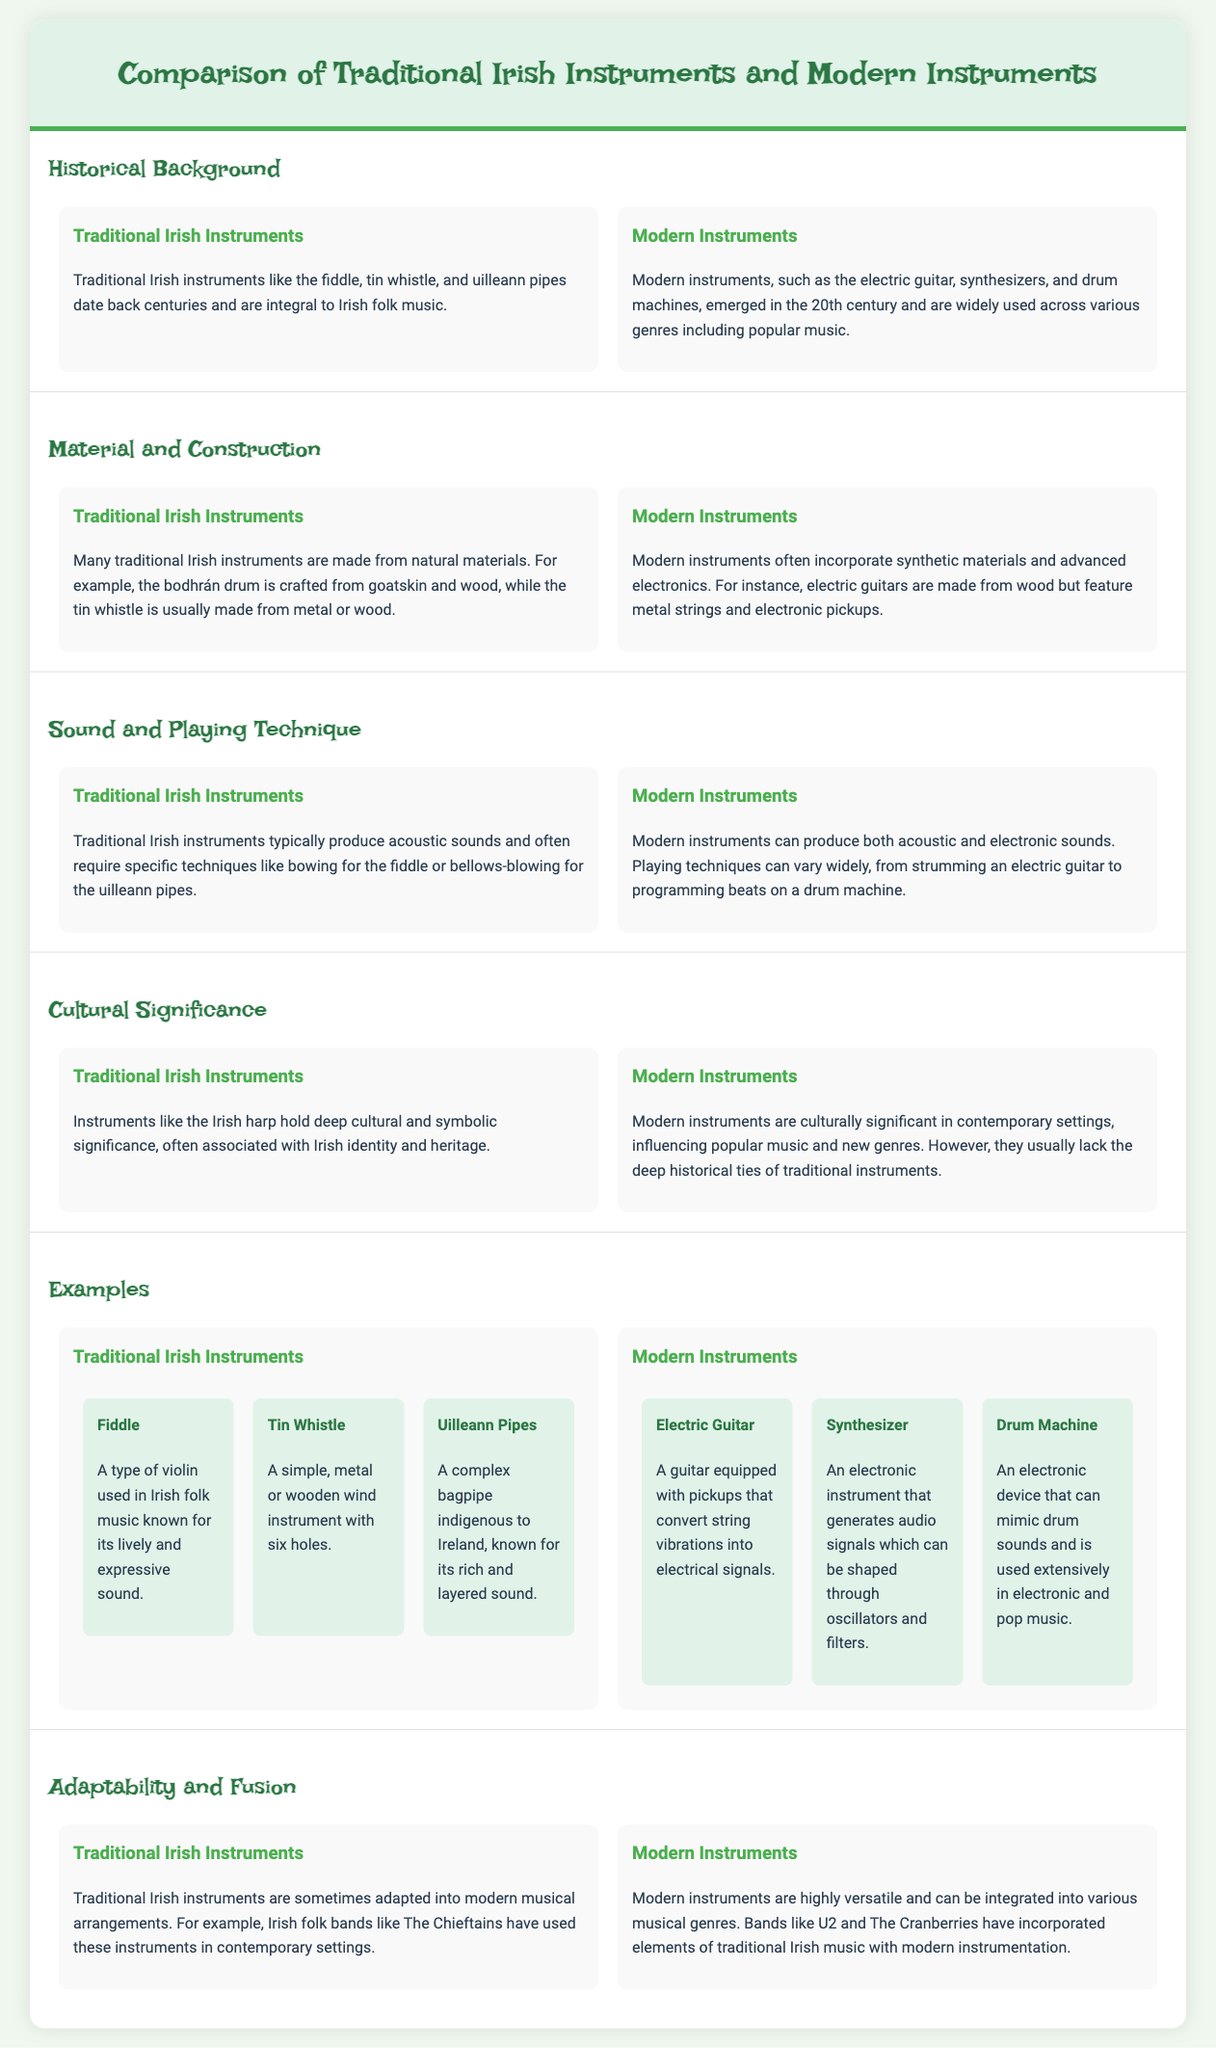What are some examples of traditional Irish instruments? The examples of traditional Irish instruments listed in the document include the fiddle, tin whistle, and uilleann pipes.
Answer: fiddle, tin whistle, uilleann pipes When did modern instruments emerge? The document states that modern instruments like the electric guitar, synthesizers, and drum machines emerged in the 20th century.
Answer: 20th century What material is the bodhrán drum made from? The bodhrán drum is crafted from goatskin and wood, as mentioned in the document.
Answer: goatskin and wood How do traditional Irish instruments typically produce sound? Traditional Irish instruments typically produce acoustic sounds and often require specific techniques like bowing or bellows-blowing.
Answer: acoustic sounds Which modern instrument is known for mimicking drum sounds? The document identifies the drum machine as an electronic device that can mimic drum sounds.
Answer: drum machine What is a key difference in cultural significance between traditional and modern instruments? Traditional instruments have deep historical ties, while modern instruments influence popular music but lack this depth.
Answer: deep historical ties What construction materials are commonly used in modern instruments? Modern instruments often incorporate synthetic materials and advanced electronics.
Answer: synthetic materials and advanced electronics Which band is mentioned as adapting traditional Irish instruments? The Chieftains are mentioned as an example of a band that adapts traditional Irish instruments into modern arrangements.
Answer: The Chieftains 